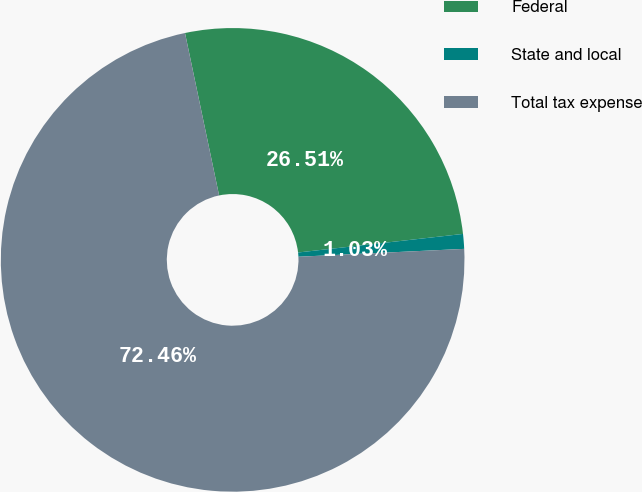Convert chart to OTSL. <chart><loc_0><loc_0><loc_500><loc_500><pie_chart><fcel>Federal<fcel>State and local<fcel>Total tax expense<nl><fcel>26.51%<fcel>1.03%<fcel>72.46%<nl></chart> 